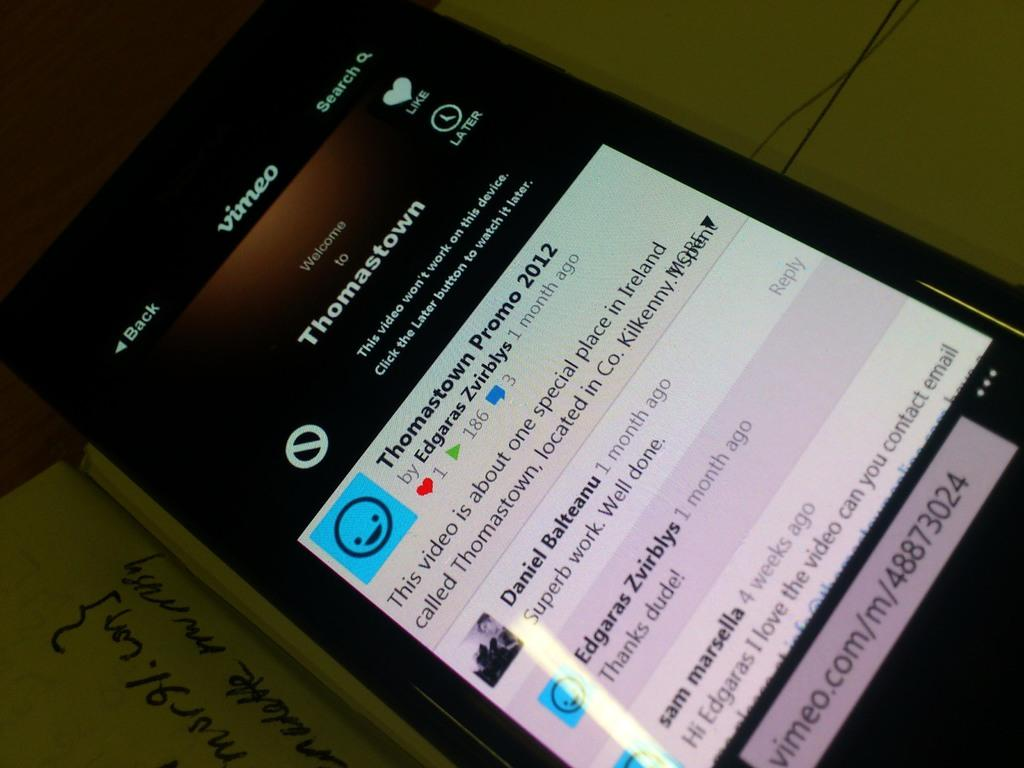<image>
Offer a succinct explanation of the picture presented. On a cellphone screen, Thomastown information appears with a video link. 